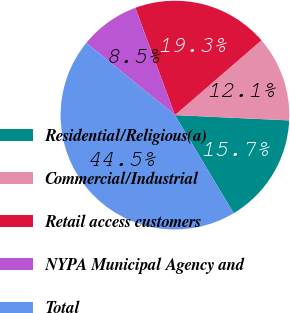Convert chart. <chart><loc_0><loc_0><loc_500><loc_500><pie_chart><fcel>Residential/Religious(a)<fcel>Commercial/Industrial<fcel>Retail access customers<fcel>NYPA Municipal Agency and<fcel>Total<nl><fcel>15.68%<fcel>12.09%<fcel>19.28%<fcel>8.49%<fcel>44.46%<nl></chart> 